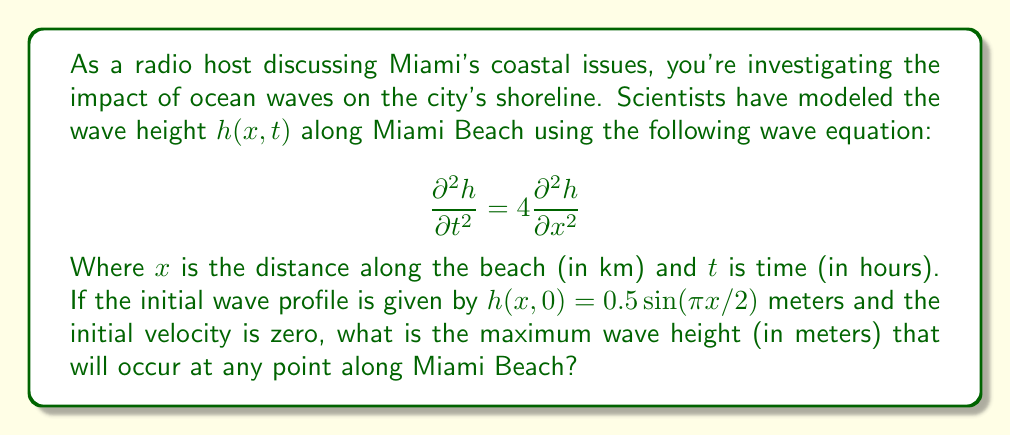Teach me how to tackle this problem. Let's approach this step-by-step:

1) The general solution for this wave equation is of the form:

   $$h(x,t) = [A \cos(ωt) + B \sin(ωt)] \sin(kx)$$

   where $ω = 2k$ (from the wave equation), and $k$ is the wave number.

2) Given the initial condition $h(x,0) = 0.5 \sin(\pi x/2)$, we can determine:
   
   $k = \pi/2$ and $A = 0.5$

3) The initial velocity being zero means:

   $$\frac{\partial h}{\partial t}(x,0) = 0$$

   This implies $B = 0$

4) Therefore, our specific solution is:

   $$h(x,t) = 0.5 \cos(πt) \sin(\pi x/2)$$

5) To find the maximum wave height, we need to maximize this function:

   $$|h(x,t)| = |0.5 \cos(πt) \sin(\pi x/2)|$$

6) The maximum value of $|\cos(πt)|$ is 1, and the maximum value of $|\sin(\pi x/2)|$ is also 1.

7) Therefore, the maximum possible value of $|h(x,t)|$ is:

   $$0.5 * 1 * 1 = 0.5$$

Thus, the maximum wave height that will occur at any point along Miami Beach is 0.5 meters.
Answer: 0.5 meters 